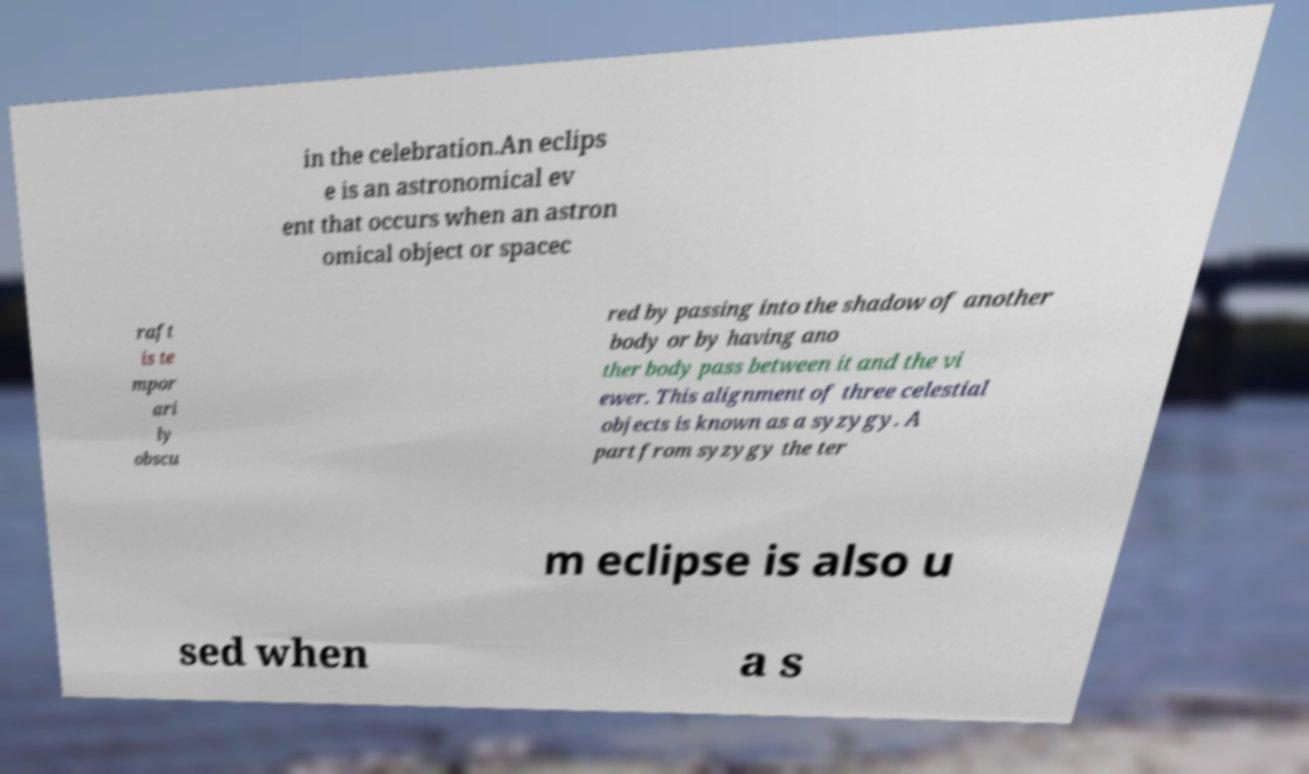What messages or text are displayed in this image? I need them in a readable, typed format. in the celebration.An eclips e is an astronomical ev ent that occurs when an astron omical object or spacec raft is te mpor ari ly obscu red by passing into the shadow of another body or by having ano ther body pass between it and the vi ewer. This alignment of three celestial objects is known as a syzygy. A part from syzygy the ter m eclipse is also u sed when a s 